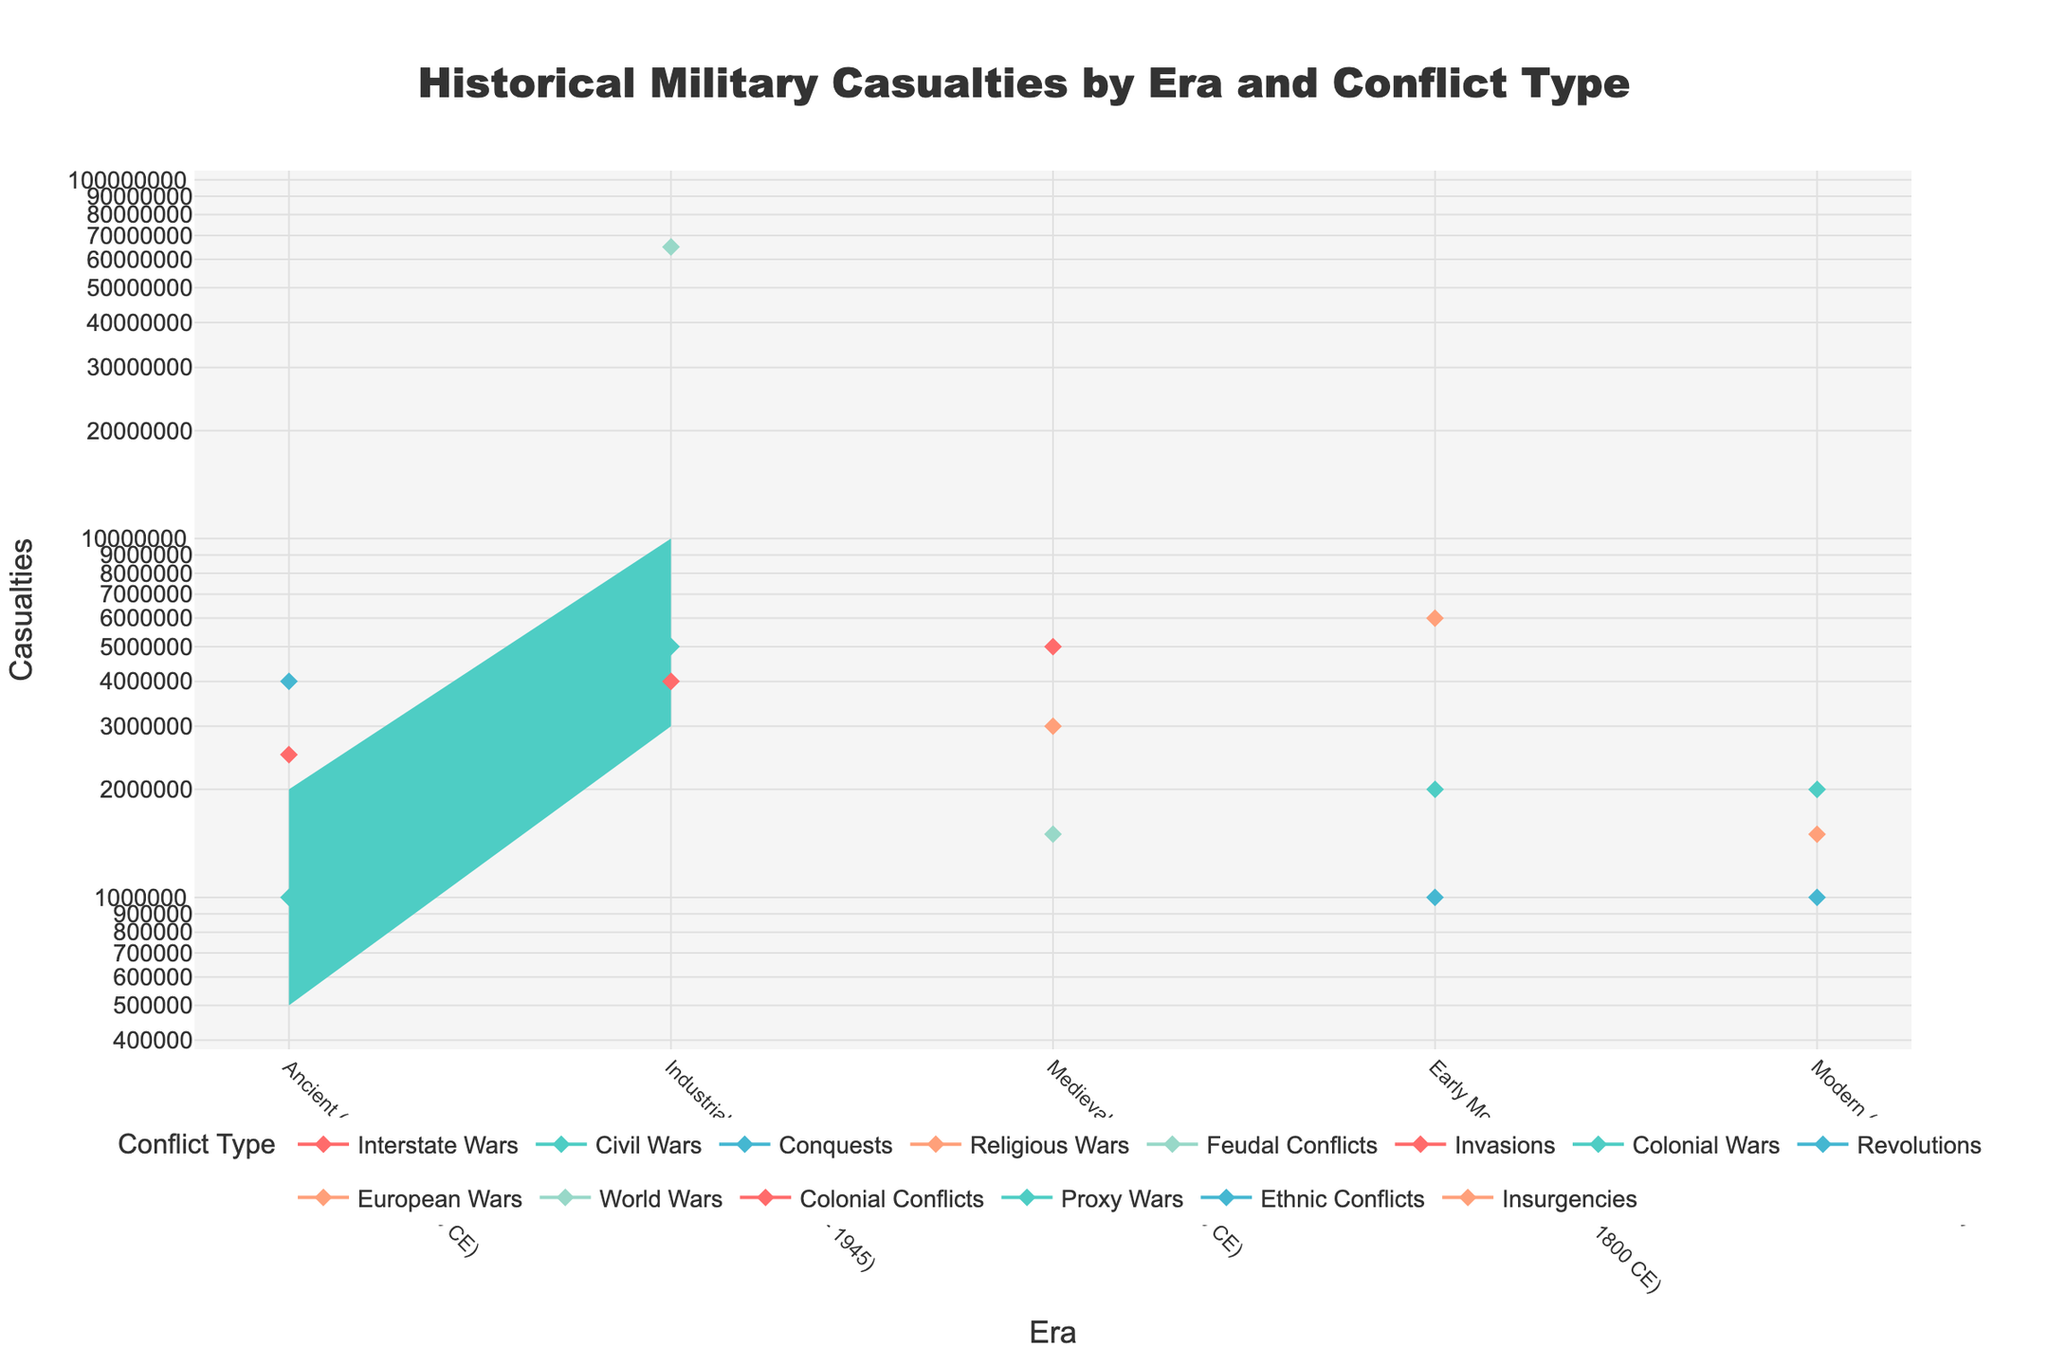Which era shows the highest mid-estimate casualties for a single conflict type? To answer this, we look at the mid-estimate figures for each conflict type in each era and compare them. The highest mid-estimate is 65,000,000 in the Industrial Age for World Wars.
Answer: Industrial Age What is the range of casualties for Feudal Conflicts in the Medieval era? The range is found by subtracting the low estimate from the high estimate for Feudal Conflicts in the Medieval era: 3,000,000 - 750,000 = 2,250,000.
Answer: 2,250,000 Which conflict type in the Early Modern era has the lowest high estimate of casualties? Compare the high estimate figures for each conflict type in the Early Modern era. The lowest high estimate is for Revolutions, which is 2,000,000.
Answer: Revolutions Between Civil Wars in the Ancient era and Insurgencies in the Modern era, which has a higher average mid-estimate of casualties? First, calculate the mid-estimate for both: Civil Wars in Ancient era (1,000,000) and Insurgencies in Modern era (1,500,000). Compare the two values.
Answer: Insurgencies in Modern era How does the low estimate of casualties for Interstate Wars in the Ancient era compare to the mid-estimate for Revolutions in the Early Modern era? The low estimate for Interstate Wars in the Ancient era is 1,000,000, and the mid-estimate for Revolutions in the Early Modern era is also 1,000,000. They are equal.
Answer: Equal Which conflict type has the broadest range of casualties in the Industrial Age? The range is the difference between high and low estimates. Compare ranges for each conflict type in the Industrial Age: World Wars (60,000,000), Colonial Conflicts (6,000,000), and Civil Wars (7,000,000). World Wars have the broadest range.
Answer: World Wars List the eras where Colonial Wars are present and their mid-estimate casualties. Identify the eras that have Colonial Wars: Early Modern and Industrial Age. The mid-estimate casualties are 2,000,000 and 4,000,000 respectively.
Answer: Early Modern: 2,000,000; Industrial Age: 4,000,000 How does the color coding help differentiate between conflict types in the chart? Each conflict type is assigned a distinct color, making it easy to visually distinguish between different types of conflicts across eras. For example, if Colonial Wars have a specific color like blue, all lines and areas representing Colonial Wars will be in blue.
Answer: Distinguishes conflict types Which era has consistently increasing casualty estimates in all its conflict types from low to high? Check each era to see where all conflict types have a clear increase from low to mid to high estimates. The Industrial Age shows this trend, with each conflict type following the progression from low to mid to high estimates.
Answer: Industrial Age 